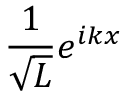Convert formula to latex. <formula><loc_0><loc_0><loc_500><loc_500>\frac { 1 } { \sqrt { L } } e ^ { i k x }</formula> 